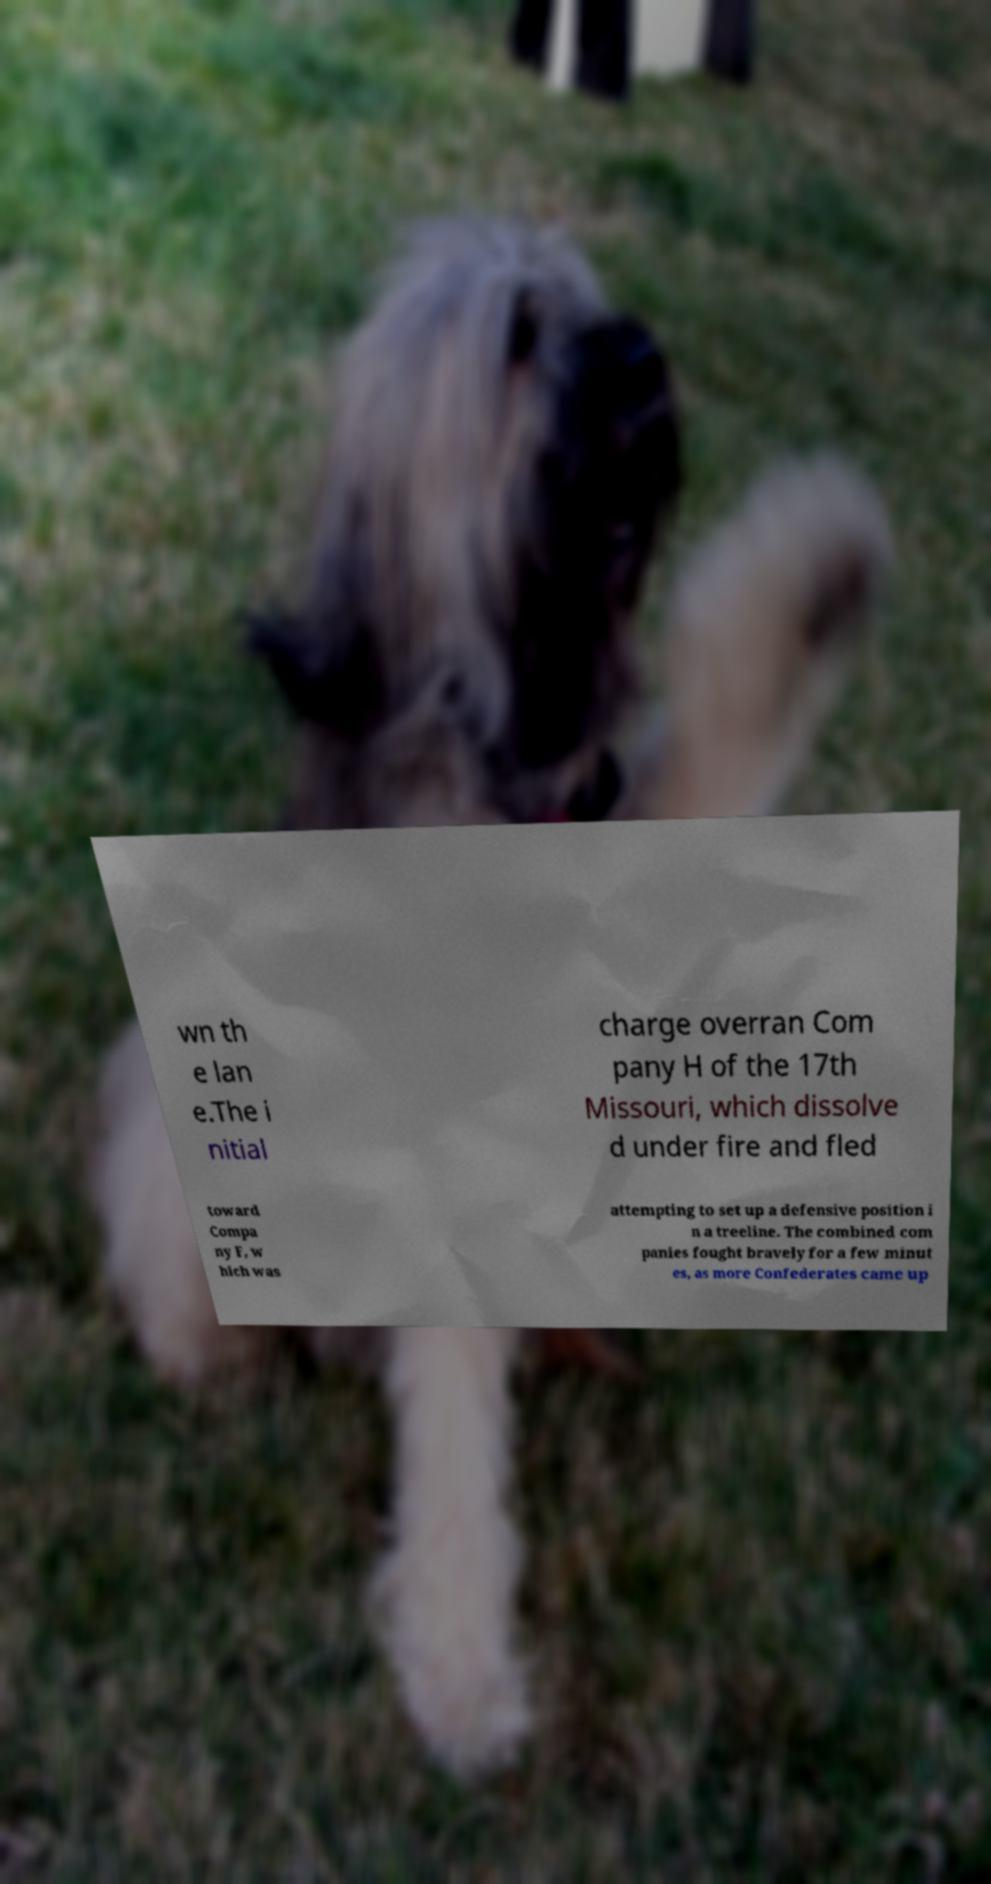Could you assist in decoding the text presented in this image and type it out clearly? wn th e lan e.The i nitial charge overran Com pany H of the 17th Missouri, which dissolve d under fire and fled toward Compa ny F, w hich was attempting to set up a defensive position i n a treeline. The combined com panies fought bravely for a few minut es, as more Confederates came up 